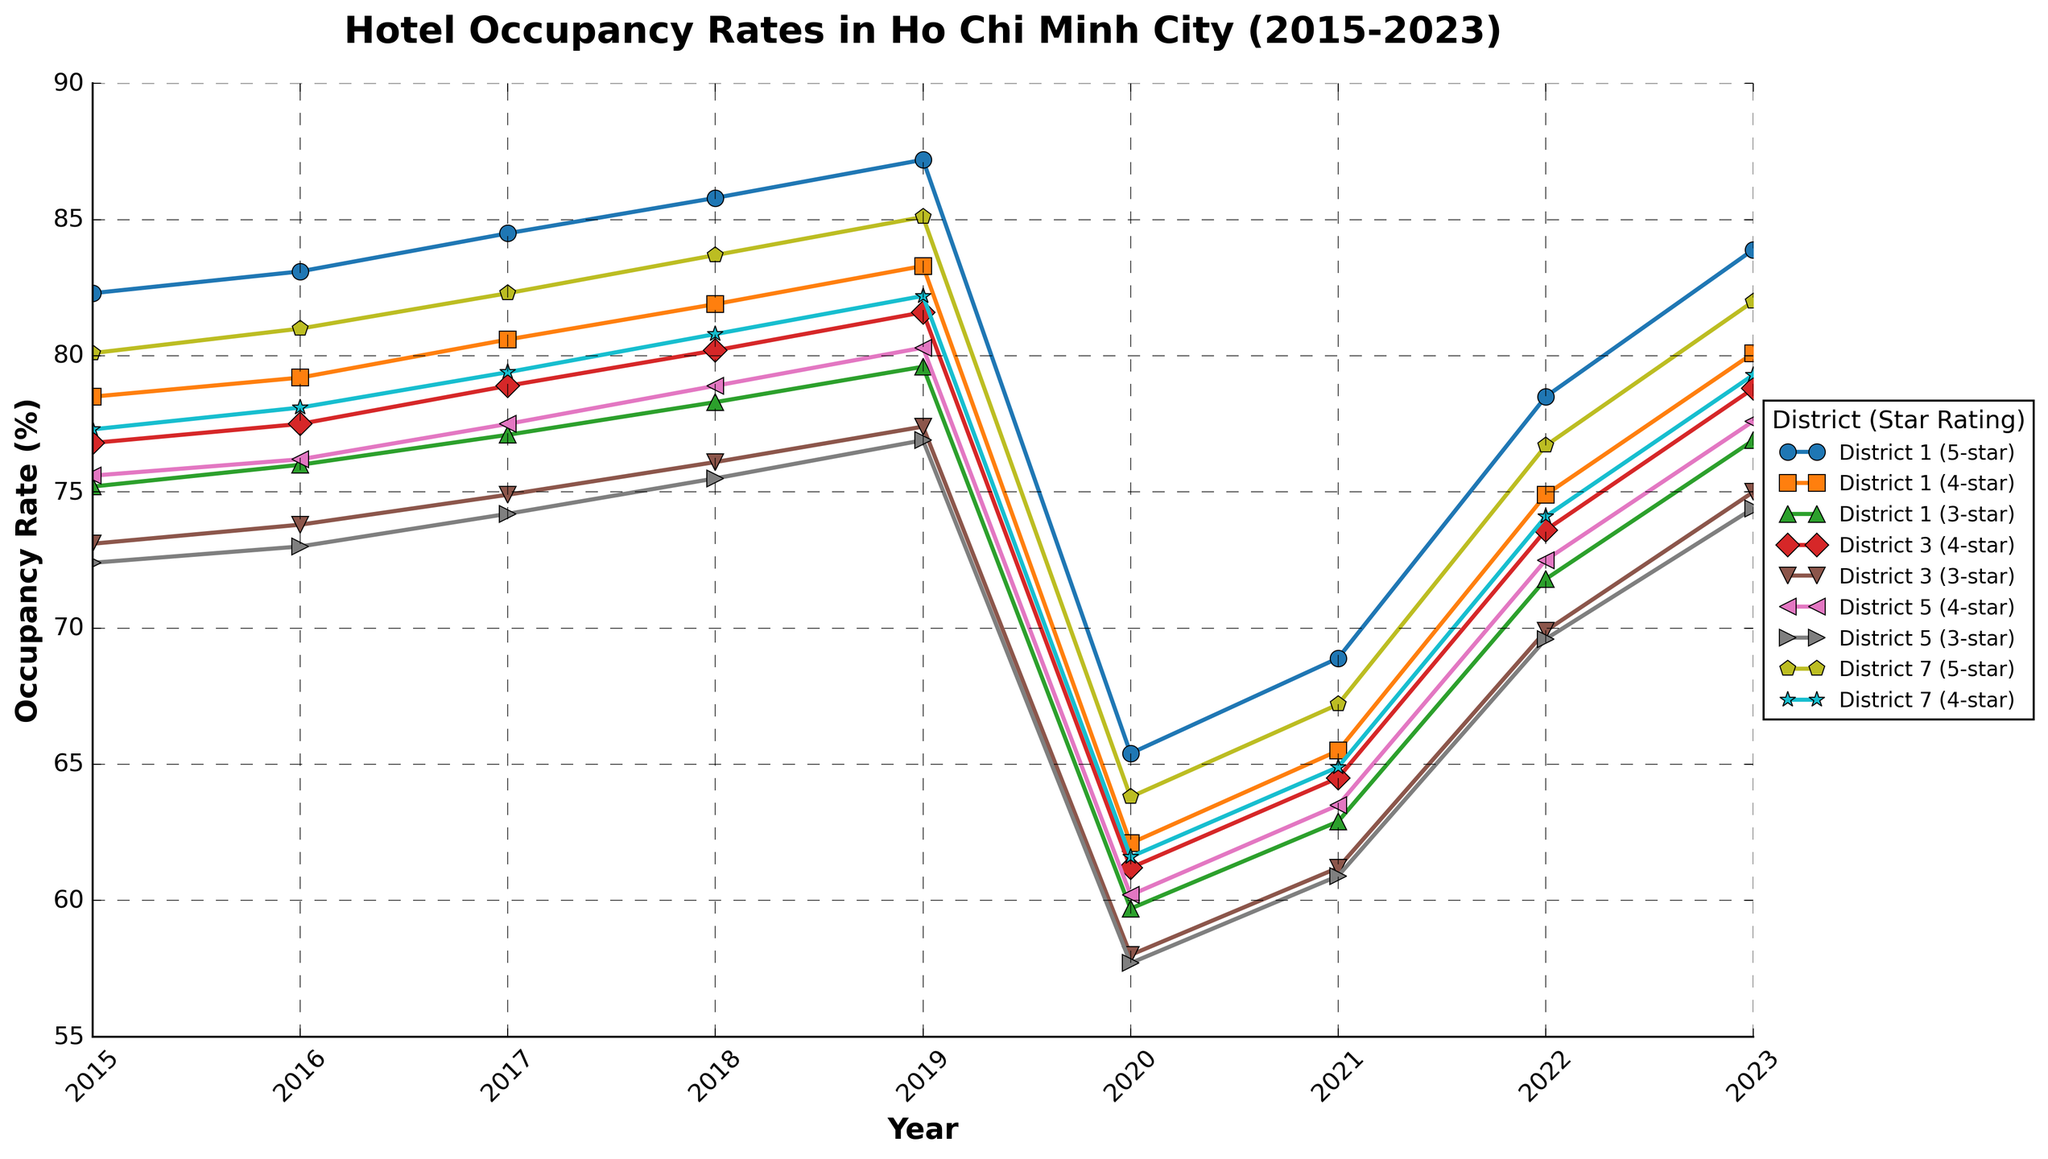What was the occupancy rate of 4-star hotels in District 1 in 2017? Look at the line for District 1 (4-star) in 2017 to find the occupancy rate. The occupancy rate for District 1 (4-star) hotels in 2017 is 80.6%.
Answer: 80.6% Which district and star rating had the lowest occupancy rate in 2020? Check all lines for occupancy rates in 2020 and identify the lowest point. The lowest point in 2020 corresponds to District 5 (3-star) with an occupancy rate of 57.7%.
Answer: District 5 (3-star) How did the occupancy rates for 5-star hotels in District 1 change from 2019 to 2021? Check the trend line for District 1 (5-star) from 2019 to 2021 to identify the changes. The occupancy rate for District 1 (5-star) hotels decreased from 87.2% in 2019 to 65.4% in 2020 and then increased to 68.9% in 2021.
Answer: Decreased then increased What is the difference in occupancy rates between 4-star hotels in District 1 and 4-star hotels in District 5 in 2023? Find the occupancy rates for both districts in 2023, then subtract the 4-star rate of District 5 from the 4-star rate of District 1. The difference is 80.1% (District 1) - 77.6% (District 5) = 2.5%.
Answer: 2.5% Which district and star rating had the highest occupancy rate in 2019? Check all lines for occupancy rates in 2019 and identify the highest point. The highest occupancy rate in 2019 is for 5-star hotels in District 1, with an occupancy rate of 87.2%.
Answer: District 1 (5-star) What was the overall trend for 3-star hotels in District 1 from 2015 to 2023? Observe the line for District 1 (3-star) throughout the years to determine the overall trend. The trend shows a general increase from 75.2% in 2015 to 79.6% in 2019, a drop to 59.7% in 2020, and then a recovery to 76.9% in 2023.
Answer: Increase, drop, then recover Compare the occupancy rates of 4-star hotels in District 3 and District 7 in 2022. Which had a higher rate? Identify the points for 4-star hotels in District 3 and District 7 in 2022 and compare the rates. The occupancy rate for 4-star hotels in District 3 is 73.6%, and for District 7, it's 76.7%.
Answer: District 7 (4-star) How many years did the 4-star hotels in District 5 have an occupancy rate above 75%? Look at the line for District 5 (4-star) and count the years where the occupancy rate is above 75%. The occupancy rate was above 75% in 2017 (77.5%), 2018 (78.9%), 2019 (80.3%), and 2023 (77.6%), so 4 years.
Answer: 4 years 